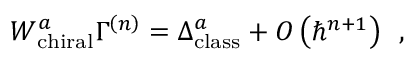Convert formula to latex. <formula><loc_0><loc_0><loc_500><loc_500>W _ { c h i r a l } ^ { a } \Gamma ^ { \left ( n \right ) } = \Delta _ { c l a s s } ^ { a } + O \left ( \hbar { ^ } { n + 1 } \right ) \, ,</formula> 